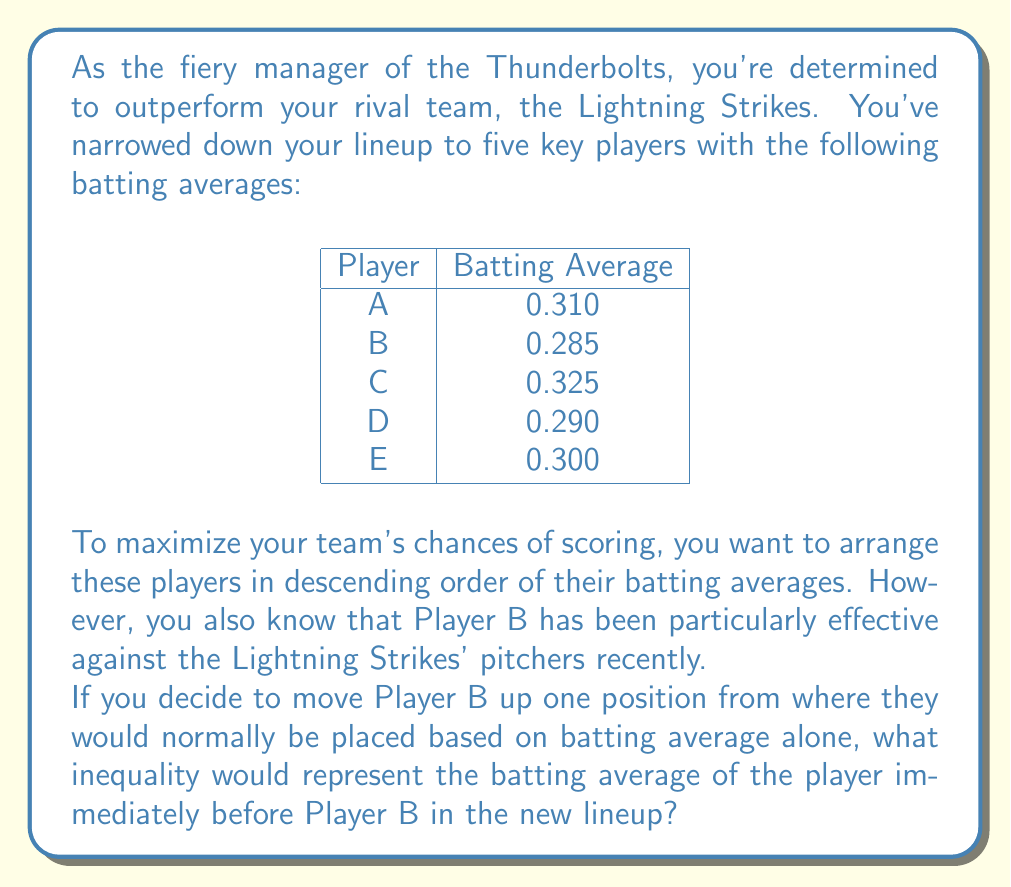Can you solve this math problem? Let's approach this step-by-step:

1) First, we need to order the players by their batting averages in descending order:

   C (0.325) > A (0.310) > E (0.300) > D (0.290) > B (0.285)

2) This would be the normal lineup order based solely on batting averages.

3) Now, we need to move Player B up one position. This means B will be placed fourth instead of fifth.

4) The new order will be:

   C (0.325) > A (0.310) > E (0.300) > B (0.285) > D (0.290)

5) We're asked about the player immediately before B in this new lineup. That's Player E.

6) We need to represent E's batting average in relation to B's. We know that E's average is greater than B's, but less than A's.

7) Therefore, the inequality representing E's batting average would be:

   $$0.285 < x < 0.310$$

   Where $x$ represents E's batting average.

This inequality shows that the batting average of the player immediately before B (which is E) is greater than B's average (0.285) but less than the next highest average (0.310).
Answer: $$0.285 < x < 0.310$$
Where $x$ represents the batting average of the player immediately before Player B in the new lineup. 